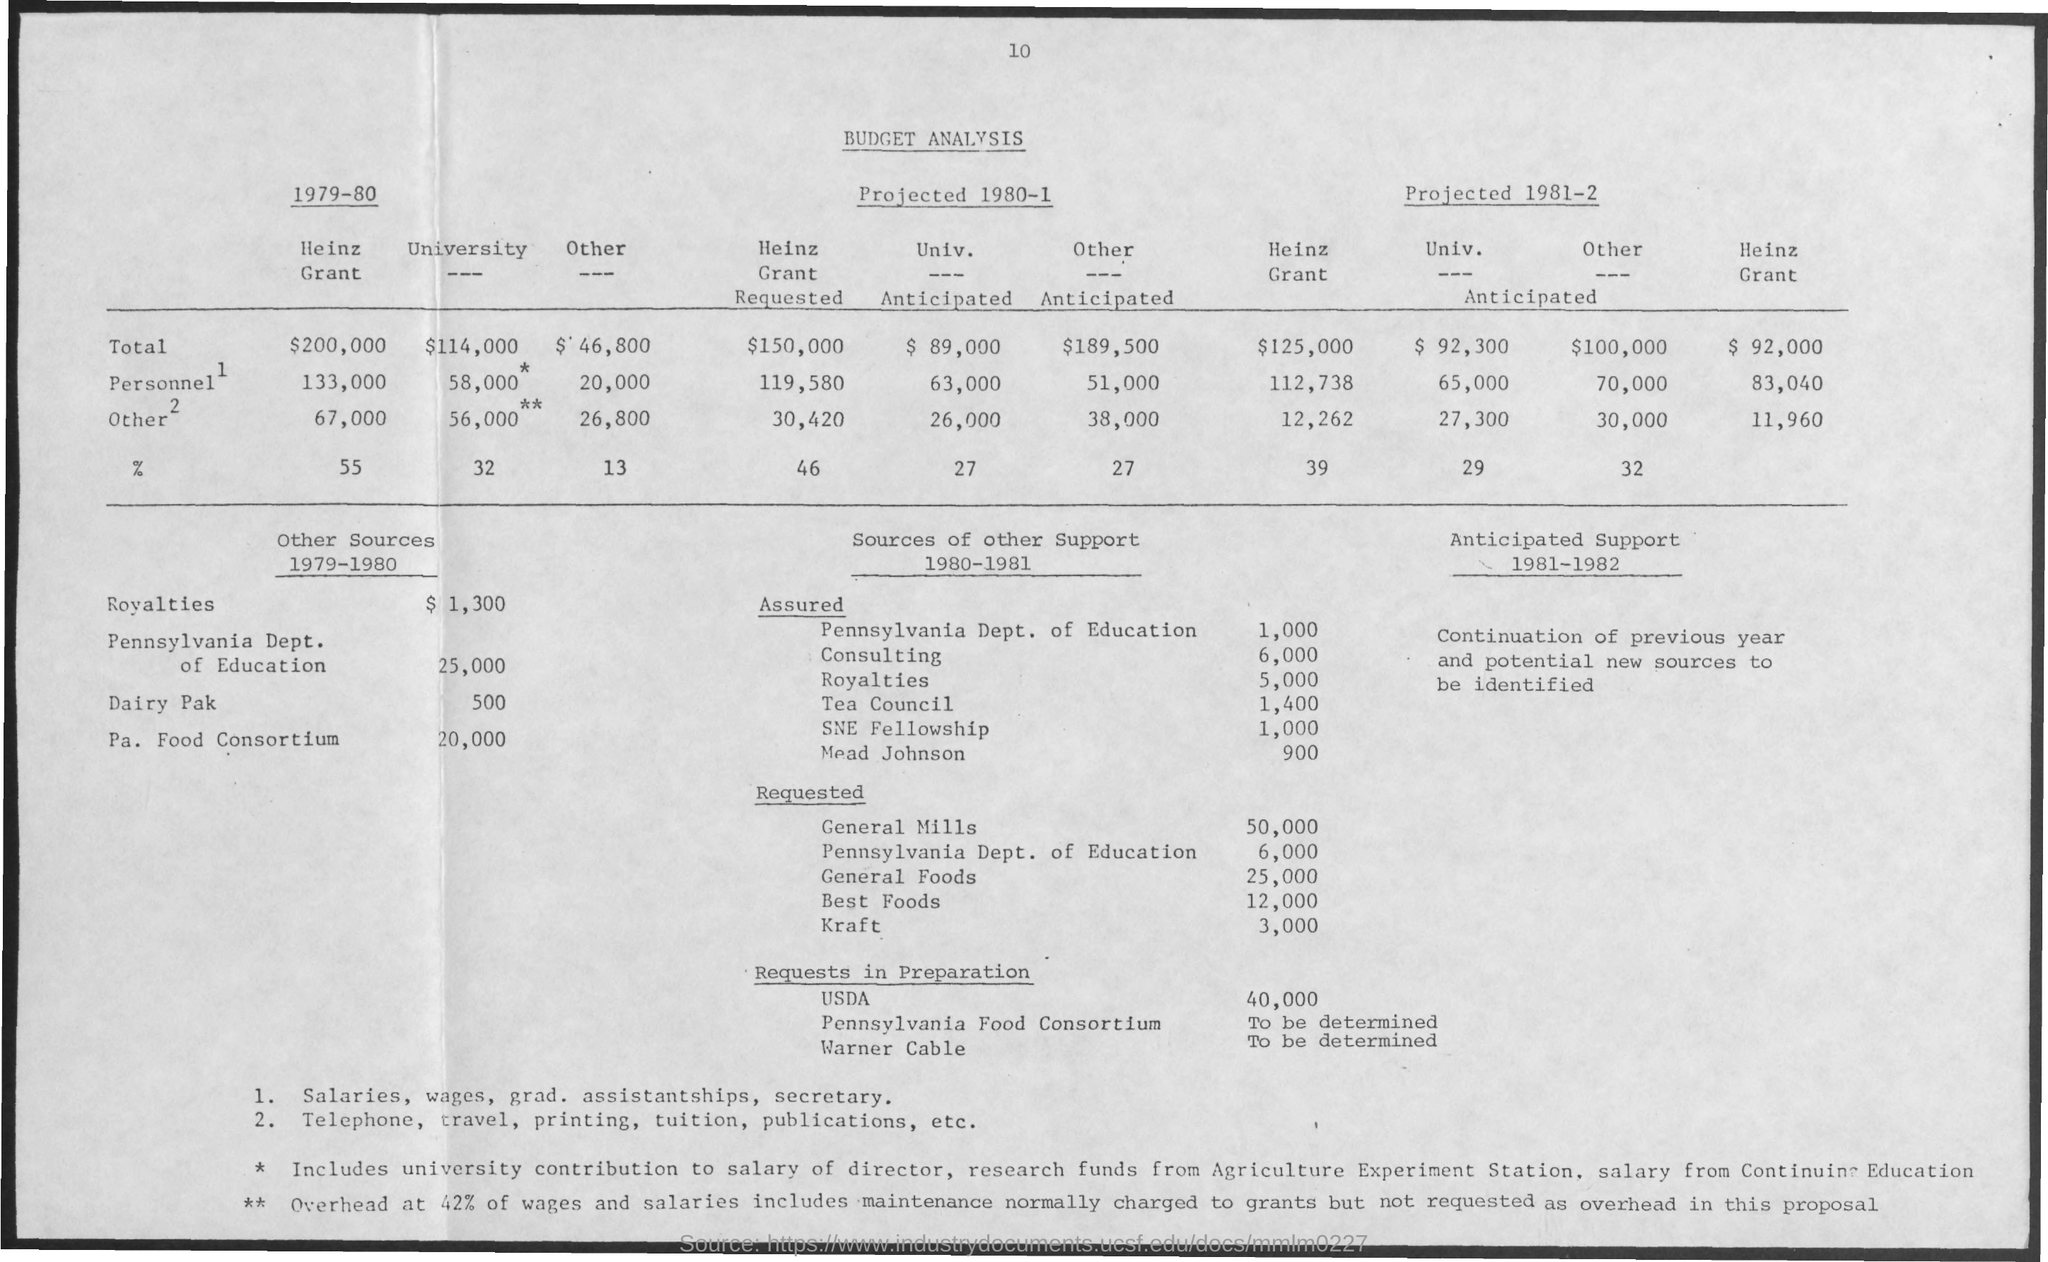Indicate a few pertinent items in this graphic. The page number is 10. The title of the document is 'Budget Analysis.' 